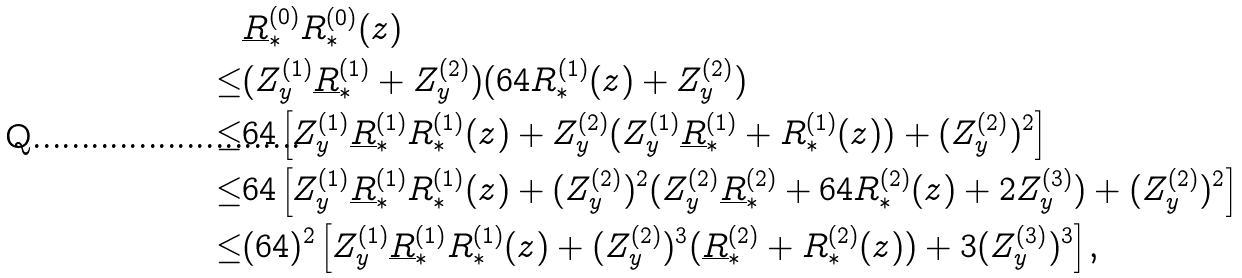<formula> <loc_0><loc_0><loc_500><loc_500>& \underline { R } _ { * } ^ { ( 0 ) } R _ { * } ^ { ( 0 ) } ( z ) \\ \leq & ( Z _ { y } ^ { ( 1 ) } \underline { R } _ { * } ^ { ( 1 ) } + Z _ { y } ^ { ( 2 ) } ) ( 6 4 R _ { * } ^ { ( 1 ) } ( z ) + Z _ { y } ^ { ( 2 ) } ) \\ \leq & 6 4 \left [ Z _ { y } ^ { ( 1 ) } \underline { R } _ { * } ^ { ( 1 ) } R _ { * } ^ { ( 1 ) } ( z ) + Z _ { y } ^ { ( 2 ) } ( Z _ { y } ^ { ( 1 ) } \underline { R } _ { * } ^ { ( 1 ) } + R _ { * } ^ { ( 1 ) } ( z ) ) + ( Z _ { y } ^ { ( 2 ) } ) ^ { 2 } \right ] \\ \leq & 6 4 \left [ Z _ { y } ^ { ( 1 ) } \underline { R } _ { * } ^ { ( 1 ) } R _ { * } ^ { ( 1 ) } ( z ) + ( Z _ { y } ^ { ( 2 ) } ) ^ { 2 } ( Z _ { y } ^ { ( 2 ) } \underline { R } _ { * } ^ { ( 2 ) } + 6 4 R _ { * } ^ { ( 2 ) } ( z ) + 2 Z _ { y } ^ { ( 3 ) } ) + ( Z _ { y } ^ { ( 2 ) } ) ^ { 2 } \right ] \\ \leq & ( 6 4 ) ^ { 2 } \left [ Z _ { y } ^ { ( 1 ) } \underline { R } _ { * } ^ { ( 1 ) } R _ { * } ^ { ( 1 ) } ( z ) + ( Z _ { y } ^ { ( 2 ) } ) ^ { 3 } ( \underline { R } _ { * } ^ { ( 2 ) } + R _ { * } ^ { ( 2 ) } ( z ) ) + 3 ( Z _ { y } ^ { ( 3 ) } ) ^ { 3 } \right ] ,</formula> 